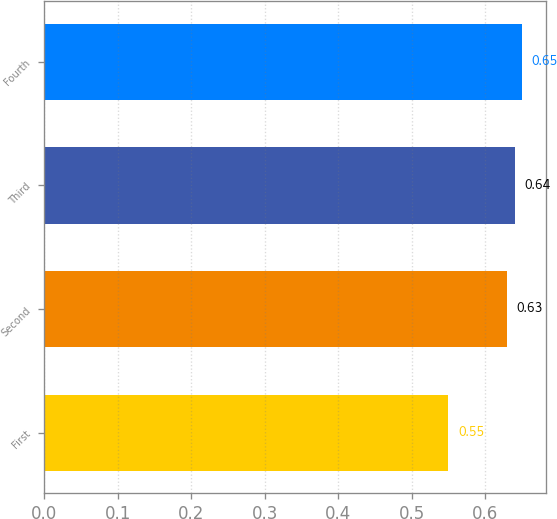Convert chart to OTSL. <chart><loc_0><loc_0><loc_500><loc_500><bar_chart><fcel>First<fcel>Second<fcel>Third<fcel>Fourth<nl><fcel>0.55<fcel>0.63<fcel>0.64<fcel>0.65<nl></chart> 